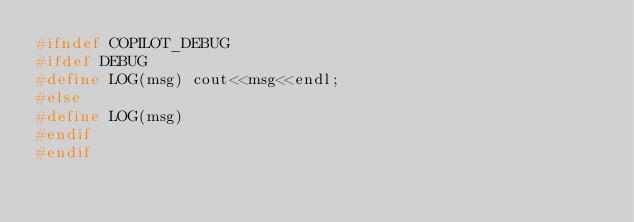Convert code to text. <code><loc_0><loc_0><loc_500><loc_500><_C_>#ifndef COPILOT_DEBUG
#ifdef DEBUG
#define LOG(msg) cout<<msg<<endl;
#else
#define LOG(msg)
#endif
#endif</code> 